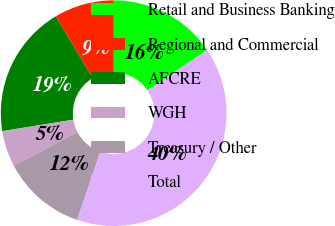Convert chart to OTSL. <chart><loc_0><loc_0><loc_500><loc_500><pie_chart><fcel>Retail and Business Banking<fcel>Regional and Commercial<fcel>AFCRE<fcel>WGH<fcel>Treasury / Other<fcel>Total<nl><fcel>15.51%<fcel>8.6%<fcel>18.97%<fcel>5.14%<fcel>12.06%<fcel>39.71%<nl></chart> 